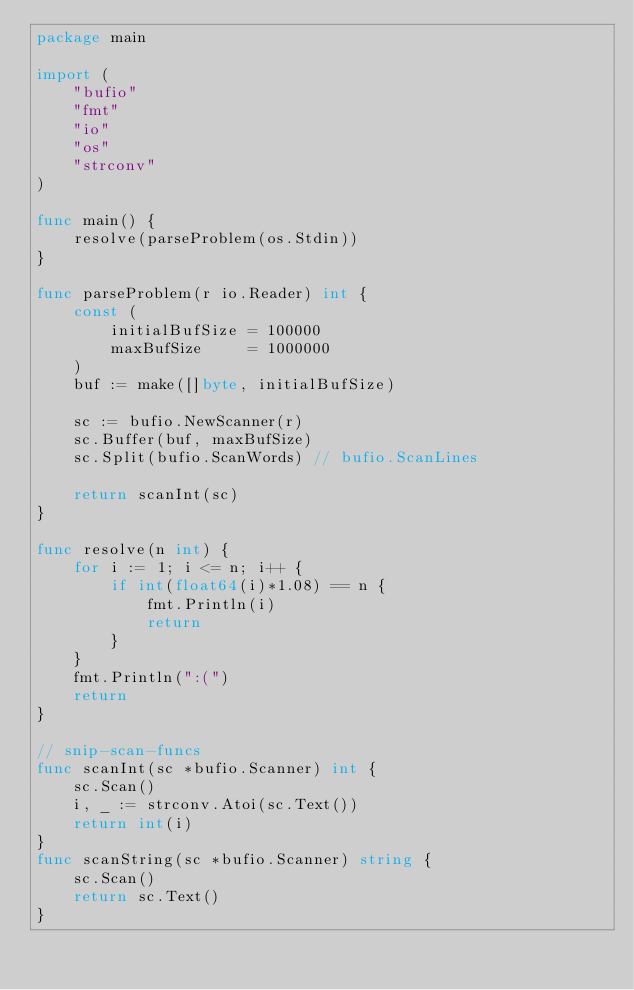Convert code to text. <code><loc_0><loc_0><loc_500><loc_500><_Go_>package main

import (
	"bufio"
	"fmt"
	"io"
	"os"
	"strconv"
)

func main() {
	resolve(parseProblem(os.Stdin))
}

func parseProblem(r io.Reader) int {
	const (
		initialBufSize = 100000
		maxBufSize     = 1000000
	)
	buf := make([]byte, initialBufSize)

	sc := bufio.NewScanner(r)
	sc.Buffer(buf, maxBufSize)
	sc.Split(bufio.ScanWords) // bufio.ScanLines

	return scanInt(sc)
}

func resolve(n int) {
	for i := 1; i <= n; i++ {
		if int(float64(i)*1.08) == n {
			fmt.Println(i)
			return
		}
	}
	fmt.Println(":(")
	return
}

// snip-scan-funcs
func scanInt(sc *bufio.Scanner) int {
	sc.Scan()
	i, _ := strconv.Atoi(sc.Text())
	return int(i)
}
func scanString(sc *bufio.Scanner) string {
	sc.Scan()
	return sc.Text()
}
</code> 